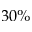Convert formula to latex. <formula><loc_0><loc_0><loc_500><loc_500>3 0 \%</formula> 